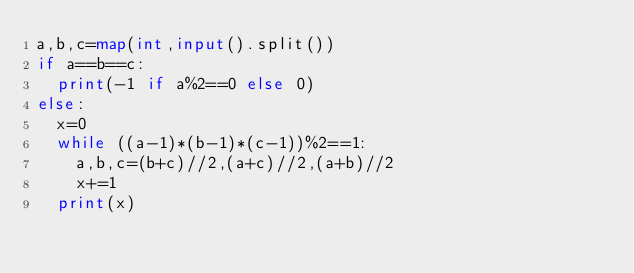Convert code to text. <code><loc_0><loc_0><loc_500><loc_500><_Python_>a,b,c=map(int,input().split())
if a==b==c:
  print(-1 if a%2==0 else 0)
else:
  x=0
  while ((a-1)*(b-1)*(c-1))%2==1:
    a,b,c=(b+c)//2,(a+c)//2,(a+b)//2
    x+=1
  print(x)</code> 